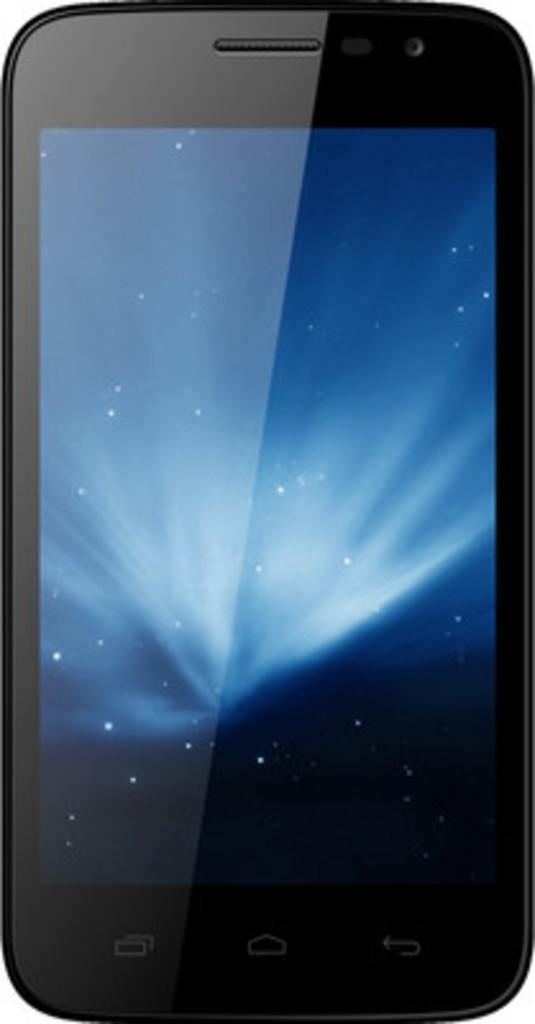What electronic device is visible in the image? There is a mobile phone in the image. What color is the background of the image? The background of the image is white in color. What type of trousers is the mobile phone wearing in the image? The mobile phone is an inanimate object and does not wear trousers. What type of eggnog can be seen in the image? There is no eggnog present in the image. 